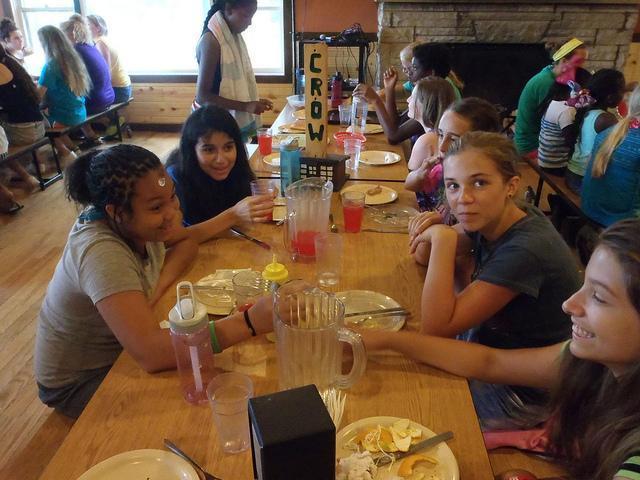How many pitchers are visible?
Give a very brief answer. 2. How many people are wearing yellow?
Give a very brief answer. 1. How many dining tables are there?
Give a very brief answer. 2. How many cups can be seen?
Give a very brief answer. 3. How many people are there?
Give a very brief answer. 13. How many benches are there?
Give a very brief answer. 1. 